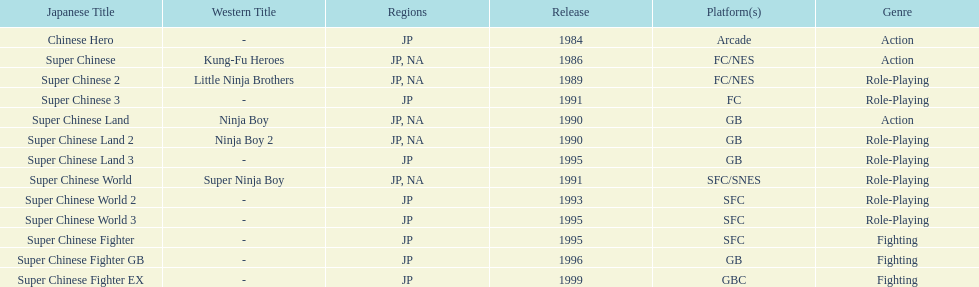How many action games were released in north america? 2. Parse the full table. {'header': ['Japanese Title', 'Western Title', 'Regions', 'Release', 'Platform(s)', 'Genre'], 'rows': [['Chinese Hero', '-', 'JP', '1984', 'Arcade', 'Action'], ['Super Chinese', 'Kung-Fu Heroes', 'JP, NA', '1986', 'FC/NES', 'Action'], ['Super Chinese 2', 'Little Ninja Brothers', 'JP, NA', '1989', 'FC/NES', 'Role-Playing'], ['Super Chinese 3', '-', 'JP', '1991', 'FC', 'Role-Playing'], ['Super Chinese Land', 'Ninja Boy', 'JP, NA', '1990', 'GB', 'Action'], ['Super Chinese Land 2', 'Ninja Boy 2', 'JP, NA', '1990', 'GB', 'Role-Playing'], ['Super Chinese Land 3', '-', 'JP', '1995', 'GB', 'Role-Playing'], ['Super Chinese World', 'Super Ninja Boy', 'JP, NA', '1991', 'SFC/SNES', 'Role-Playing'], ['Super Chinese World 2', '-', 'JP', '1993', 'SFC', 'Role-Playing'], ['Super Chinese World 3', '-', 'JP', '1995', 'SFC', 'Role-Playing'], ['Super Chinese Fighter', '-', 'JP', '1995', 'SFC', 'Fighting'], ['Super Chinese Fighter GB', '-', 'JP', '1996', 'GB', 'Fighting'], ['Super Chinese Fighter EX', '-', 'JP', '1999', 'GBC', 'Fighting']]} 